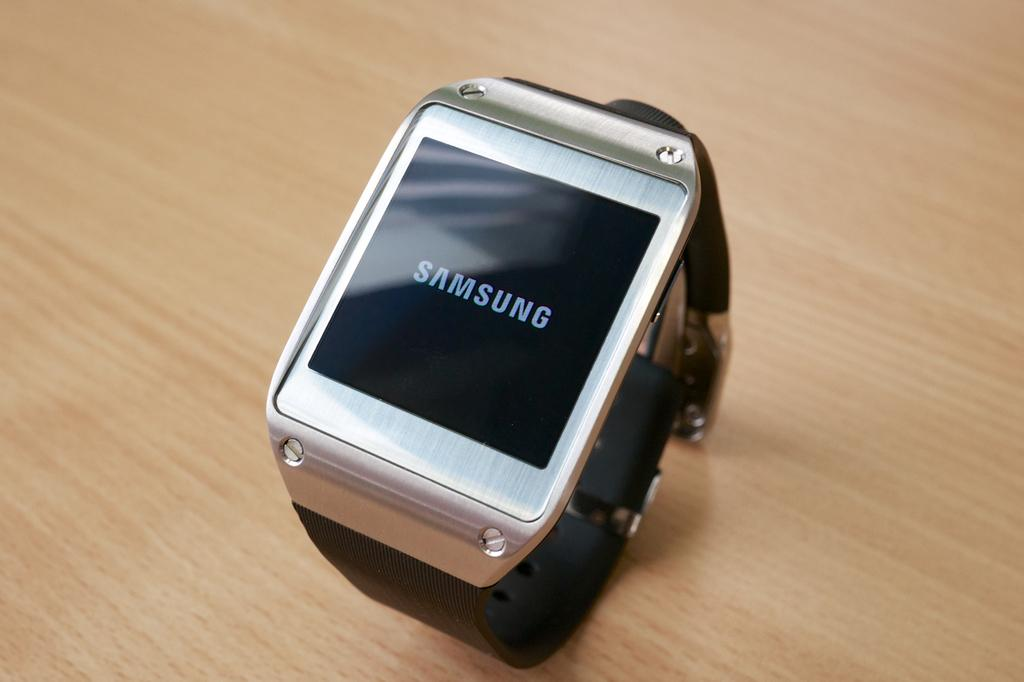What type of object is in the image? The object in the image is a wrist digital watch. Can you identify the brand of the watch? Yes, the brand name of the watch is Samsung. What type of grip does the scarecrow have on the crate in the image? There is no scarecrow or crate present in the image; it features a wrist digital watch with the brand name Samsung. 